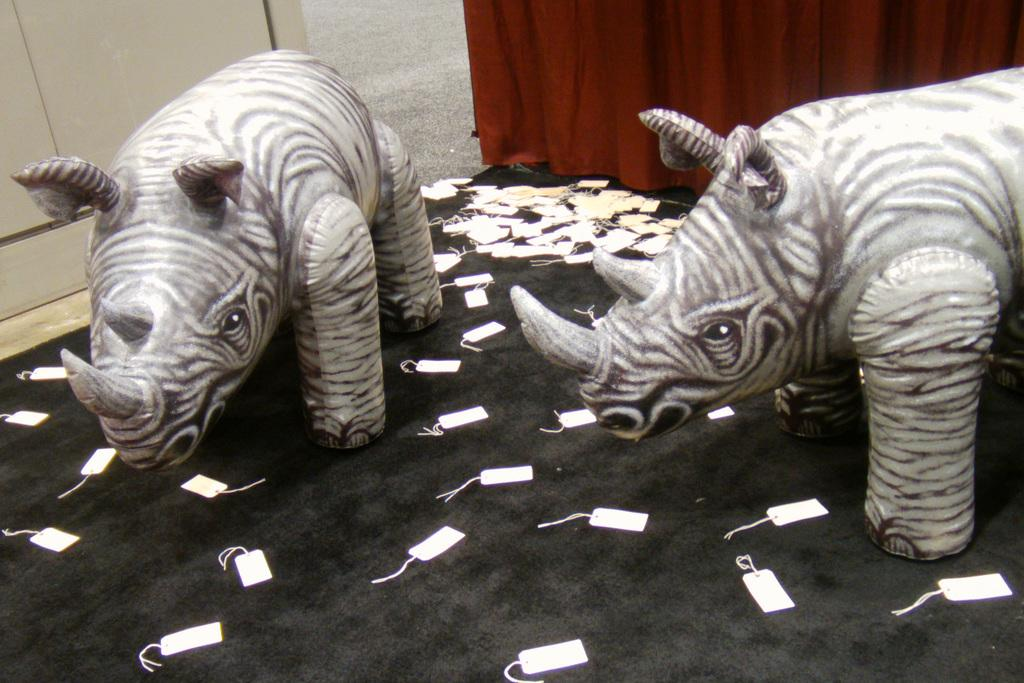What type of animals are depicted as statues in the image? There are statues of rhinos in the image. What can be seen on the floor in the image? Tags are present on the floor in the image. What is visible at the top of the image? There is a curtain visible at the top of the image. What type of cake is being served by the woman in the image? There is no woman or cake present in the image; it only features statues of rhinos, tags on the floor, and a curtain at the top. 